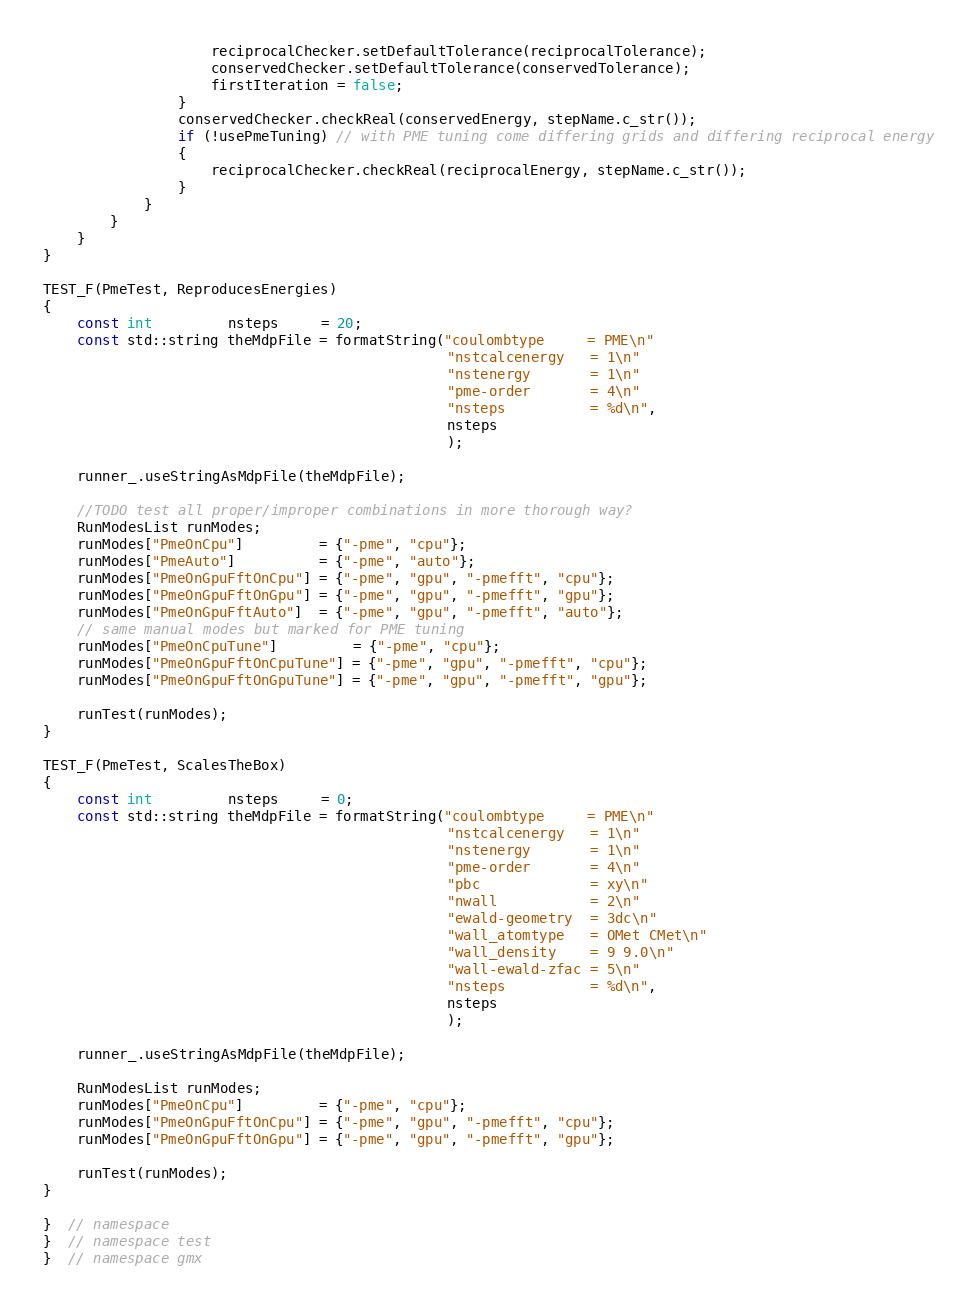<code> <loc_0><loc_0><loc_500><loc_500><_C++_>                    reciprocalChecker.setDefaultTolerance(reciprocalTolerance);
                    conservedChecker.setDefaultTolerance(conservedTolerance);
                    firstIteration = false;
                }
                conservedChecker.checkReal(conservedEnergy, stepName.c_str());
                if (!usePmeTuning) // with PME tuning come differing grids and differing reciprocal energy
                {
                    reciprocalChecker.checkReal(reciprocalEnergy, stepName.c_str());
                }
            }
        }
    }
}

TEST_F(PmeTest, ReproducesEnergies)
{
    const int         nsteps     = 20;
    const std::string theMdpFile = formatString("coulombtype     = PME\n"
                                                "nstcalcenergy   = 1\n"
                                                "nstenergy       = 1\n"
                                                "pme-order       = 4\n"
                                                "nsteps          = %d\n",
                                                nsteps
                                                );

    runner_.useStringAsMdpFile(theMdpFile);

    //TODO test all proper/improper combinations in more thorough way?
    RunModesList runModes;
    runModes["PmeOnCpu"]         = {"-pme", "cpu"};
    runModes["PmeAuto"]          = {"-pme", "auto"};
    runModes["PmeOnGpuFftOnCpu"] = {"-pme", "gpu", "-pmefft", "cpu"};
    runModes["PmeOnGpuFftOnGpu"] = {"-pme", "gpu", "-pmefft", "gpu"};
    runModes["PmeOnGpuFftAuto"]  = {"-pme", "gpu", "-pmefft", "auto"};
    // same manual modes but marked for PME tuning
    runModes["PmeOnCpuTune"]         = {"-pme", "cpu"};
    runModes["PmeOnGpuFftOnCpuTune"] = {"-pme", "gpu", "-pmefft", "cpu"};
    runModes["PmeOnGpuFftOnGpuTune"] = {"-pme", "gpu", "-pmefft", "gpu"};

    runTest(runModes);
}

TEST_F(PmeTest, ScalesTheBox)
{
    const int         nsteps     = 0;
    const std::string theMdpFile = formatString("coulombtype     = PME\n"
                                                "nstcalcenergy   = 1\n"
                                                "nstenergy       = 1\n"
                                                "pme-order       = 4\n"
                                                "pbc             = xy\n"
                                                "nwall           = 2\n"
                                                "ewald-geometry  = 3dc\n"
                                                "wall_atomtype   = OMet CMet\n"
                                                "wall_density    = 9 9.0\n"
                                                "wall-ewald-zfac = 5\n"
                                                "nsteps          = %d\n",
                                                nsteps
                                                );

    runner_.useStringAsMdpFile(theMdpFile);

    RunModesList runModes;
    runModes["PmeOnCpu"]         = {"-pme", "cpu"};
    runModes["PmeOnGpuFftOnCpu"] = {"-pme", "gpu", "-pmefft", "cpu"};
    runModes["PmeOnGpuFftOnGpu"] = {"-pme", "gpu", "-pmefft", "gpu"};

    runTest(runModes);
}

}  // namespace
}  // namespace test
}  // namespace gmx
</code> 